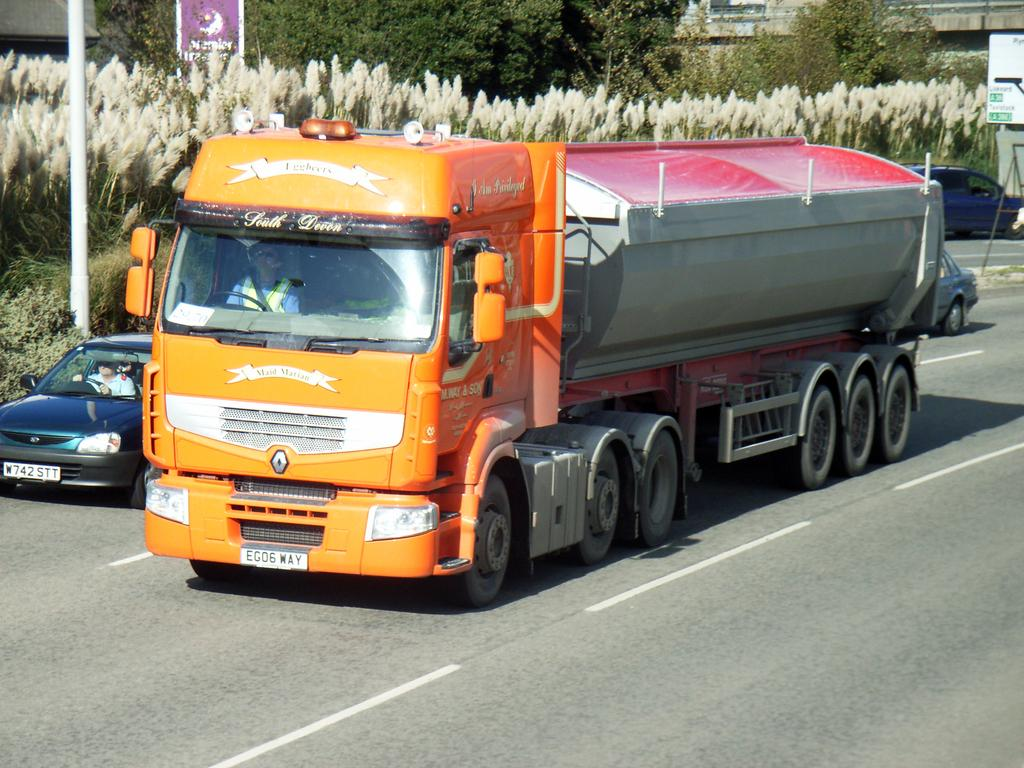How many people are in the image? There are 2 persons in the image. What are the persons doing in the image? The persons are riding a car. What else can be seen on the road in the image? There is a vehicle on the road in the image. What can be seen in the distance in the image? There are trees visible in the background of the image. What type of paper is being used by the birds in the image? There are no birds or paper present in the image. What kind of care are the persons providing to the trees in the image? The persons are not providing any care to the trees in the image; they are simply riding a car with trees visible in the background. 